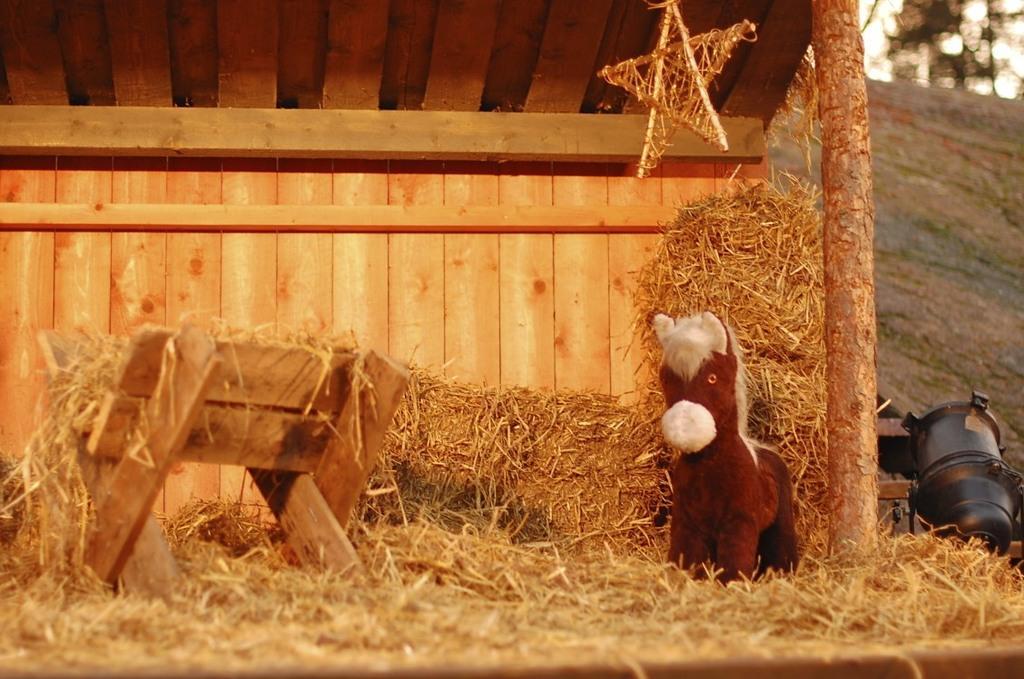Could you give a brief overview of what you see in this image? In this image we can see a wooden shed, in the shed we can see some grass, stand, toy and a star, also we can see an object on the ground which looks like a motor. 